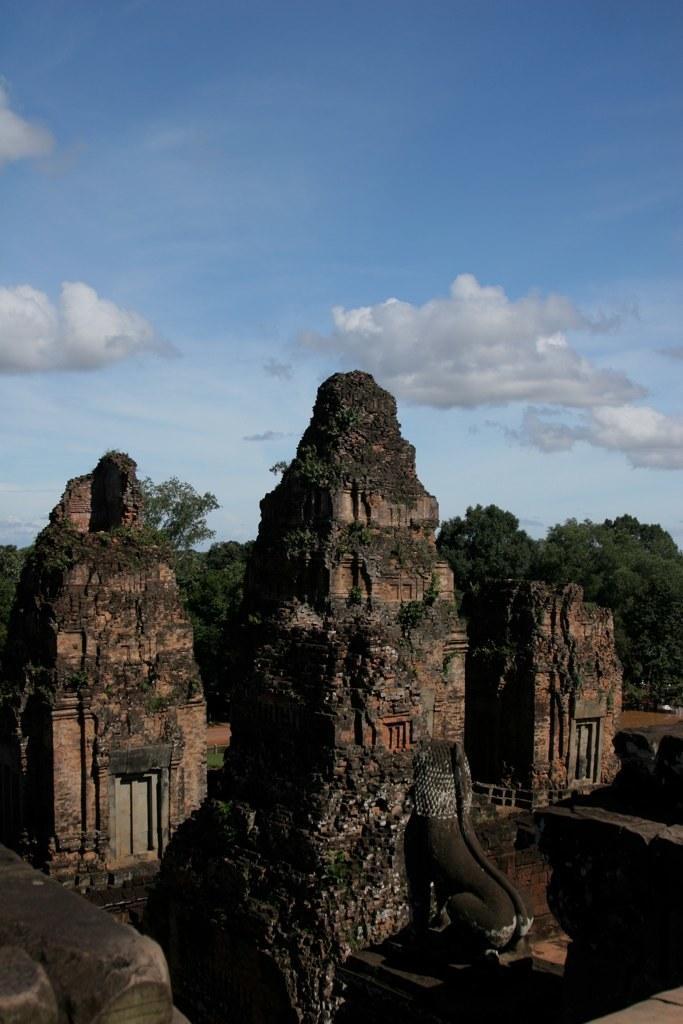Please provide a concise description of this image. In this picture we can see there are ancient architectures and a statue. Behind the architectures, there are trees and the sky. 